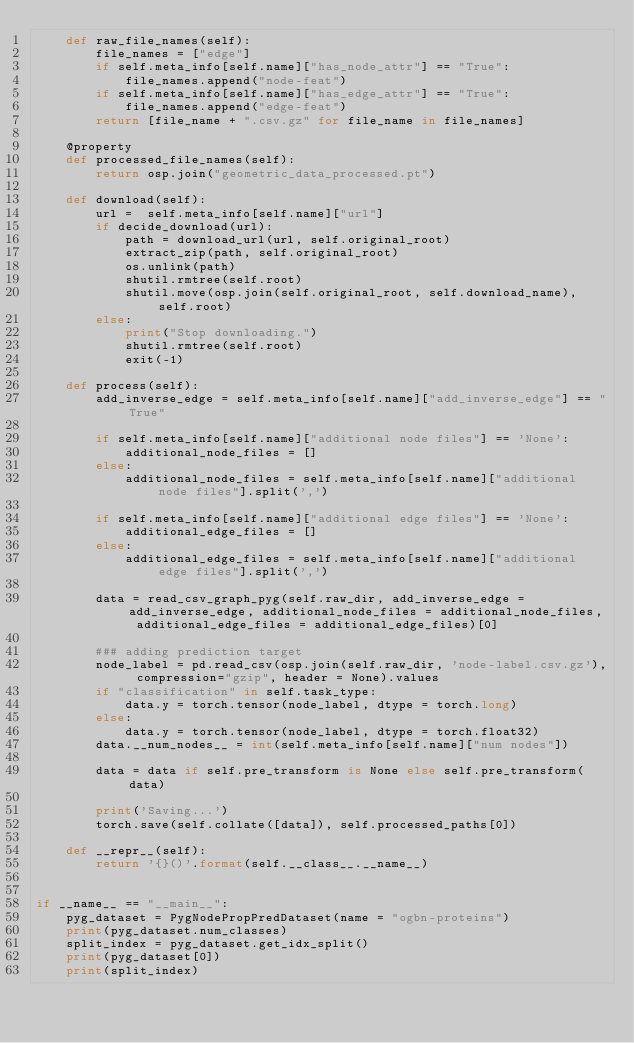Convert code to text. <code><loc_0><loc_0><loc_500><loc_500><_Python_>    def raw_file_names(self):
        file_names = ["edge"]
        if self.meta_info[self.name]["has_node_attr"] == "True":
            file_names.append("node-feat")
        if self.meta_info[self.name]["has_edge_attr"] == "True":
            file_names.append("edge-feat")
        return [file_name + ".csv.gz" for file_name in file_names]

    @property
    def processed_file_names(self):
        return osp.join("geometric_data_processed.pt")

    def download(self):
        url =  self.meta_info[self.name]["url"]
        if decide_download(url):
            path = download_url(url, self.original_root)
            extract_zip(path, self.original_root)
            os.unlink(path)
            shutil.rmtree(self.root)
            shutil.move(osp.join(self.original_root, self.download_name), self.root)
        else:
            print("Stop downloading.")
            shutil.rmtree(self.root)
            exit(-1)

    def process(self):
        add_inverse_edge = self.meta_info[self.name]["add_inverse_edge"] == "True"

        if self.meta_info[self.name]["additional node files"] == 'None':
            additional_node_files = []
        else:
            additional_node_files = self.meta_info[self.name]["additional node files"].split(',')

        if self.meta_info[self.name]["additional edge files"] == 'None':
            additional_edge_files = []
        else:
            additional_edge_files = self.meta_info[self.name]["additional edge files"].split(',')

        data = read_csv_graph_pyg(self.raw_dir, add_inverse_edge = add_inverse_edge, additional_node_files = additional_node_files, additional_edge_files = additional_edge_files)[0]

        ### adding prediction target
        node_label = pd.read_csv(osp.join(self.raw_dir, 'node-label.csv.gz'), compression="gzip", header = None).values
        if "classification" in self.task_type:
            data.y = torch.tensor(node_label, dtype = torch.long)
        else:
            data.y = torch.tensor(node_label, dtype = torch.float32)
        data.__num_nodes__ = int(self.meta_info[self.name]["num nodes"])

        data = data if self.pre_transform is None else self.pre_transform(data)

        print('Saving...')
        torch.save(self.collate([data]), self.processed_paths[0])

    def __repr__(self):
        return '{}()'.format(self.__class__.__name__)
        

if __name__ == "__main__":
    pyg_dataset = PygNodePropPredDataset(name = "ogbn-proteins")
    print(pyg_dataset.num_classes)
    split_index = pyg_dataset.get_idx_split()
    print(pyg_dataset[0])
    print(split_index)</code> 